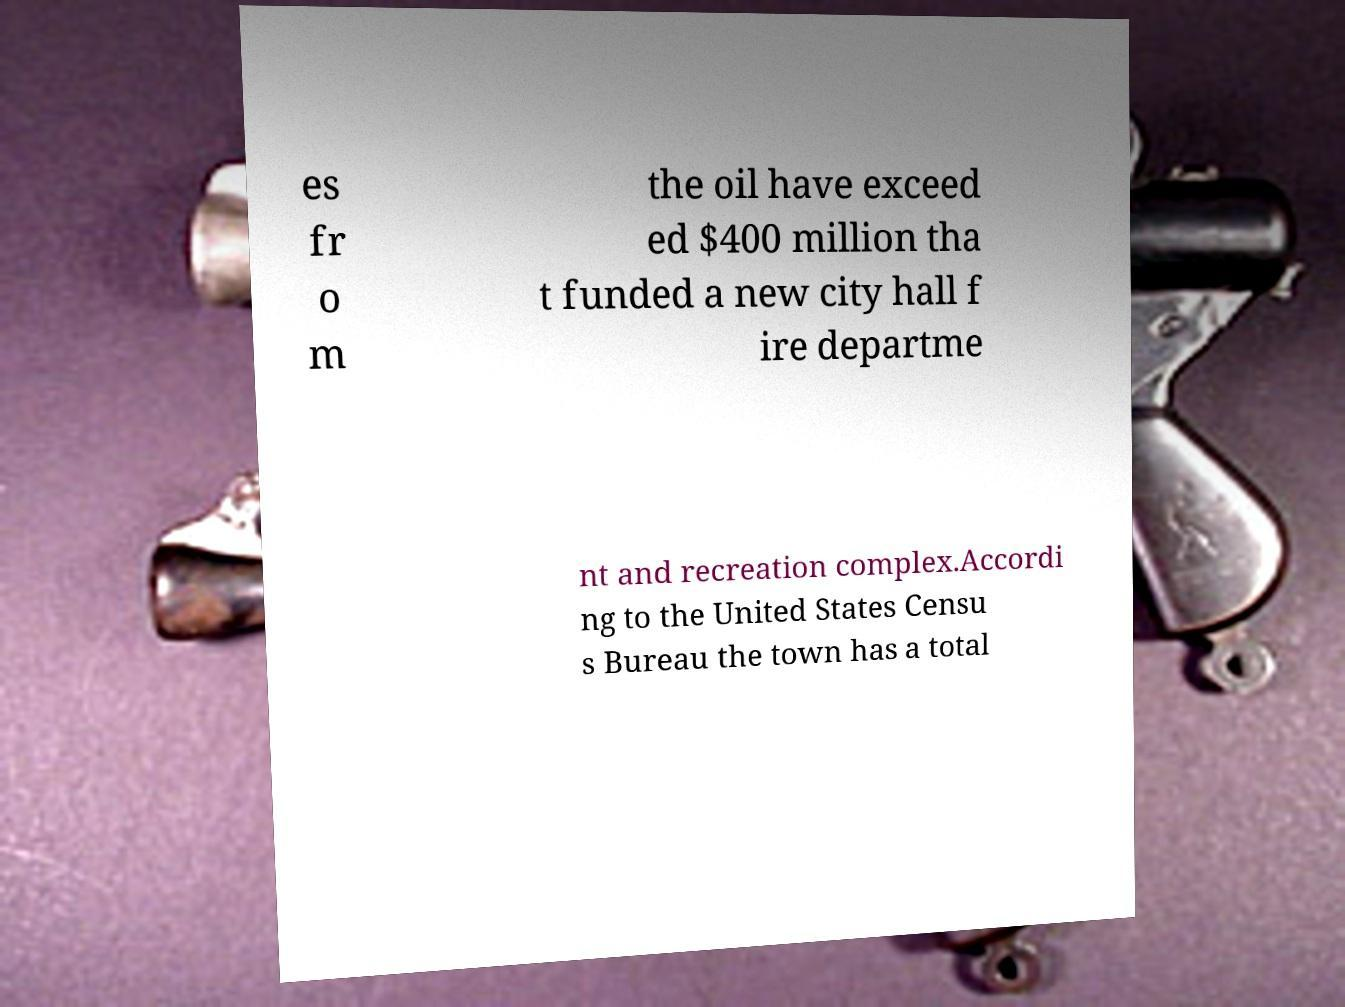Can you read and provide the text displayed in the image?This photo seems to have some interesting text. Can you extract and type it out for me? es fr o m the oil have exceed ed $400 million tha t funded a new city hall f ire departme nt and recreation complex.Accordi ng to the United States Censu s Bureau the town has a total 